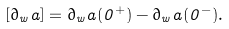<formula> <loc_0><loc_0><loc_500><loc_500>[ \partial _ { w } a ] = \partial _ { w } a ( 0 ^ { + } ) - \partial _ { w } a ( 0 ^ { - } ) .</formula> 